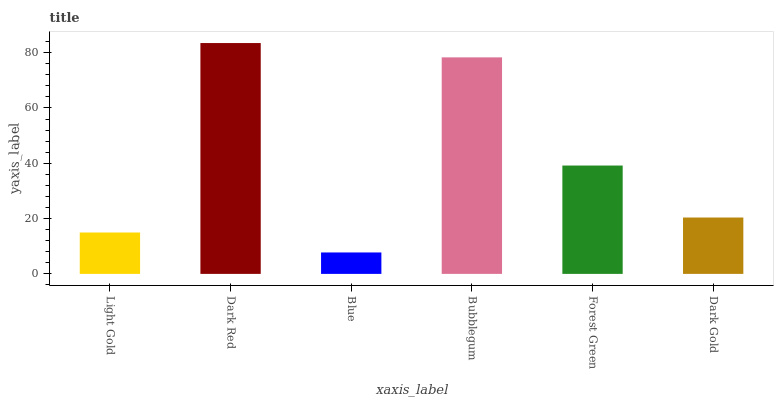Is Blue the minimum?
Answer yes or no. Yes. Is Dark Red the maximum?
Answer yes or no. Yes. Is Dark Red the minimum?
Answer yes or no. No. Is Blue the maximum?
Answer yes or no. No. Is Dark Red greater than Blue?
Answer yes or no. Yes. Is Blue less than Dark Red?
Answer yes or no. Yes. Is Blue greater than Dark Red?
Answer yes or no. No. Is Dark Red less than Blue?
Answer yes or no. No. Is Forest Green the high median?
Answer yes or no. Yes. Is Dark Gold the low median?
Answer yes or no. Yes. Is Dark Red the high median?
Answer yes or no. No. Is Dark Red the low median?
Answer yes or no. No. 